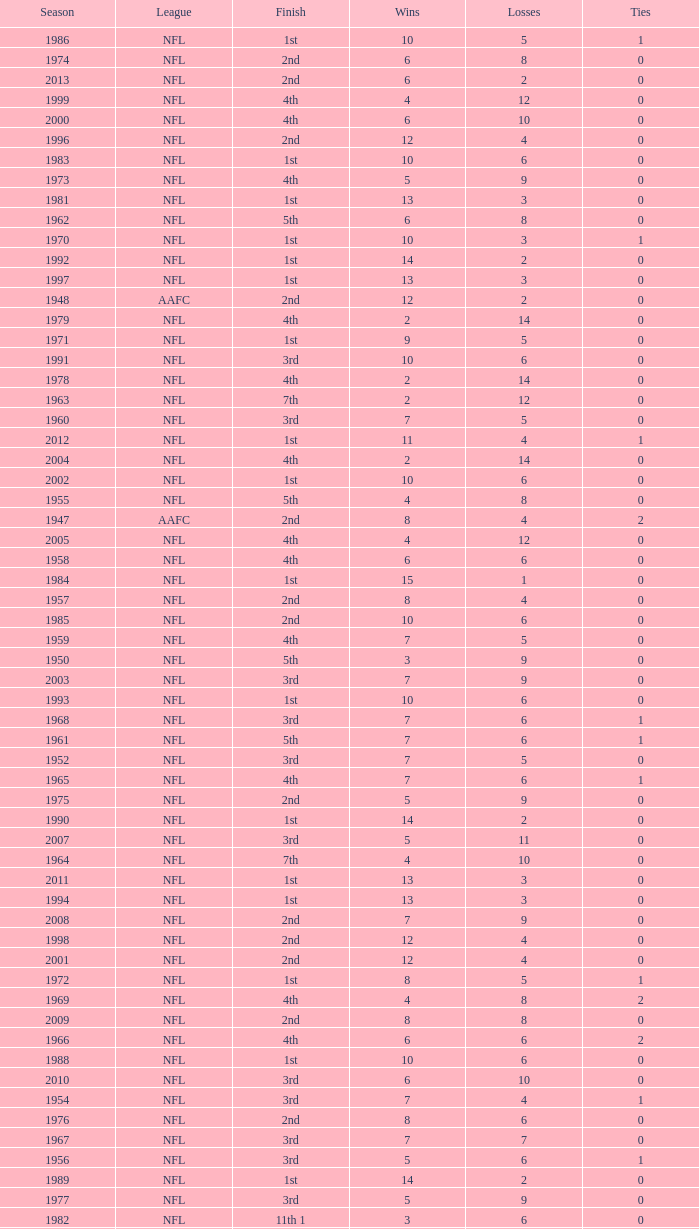What is the lowest number of ties in the NFL, with less than 2 losses and less than 15 wins? None. 